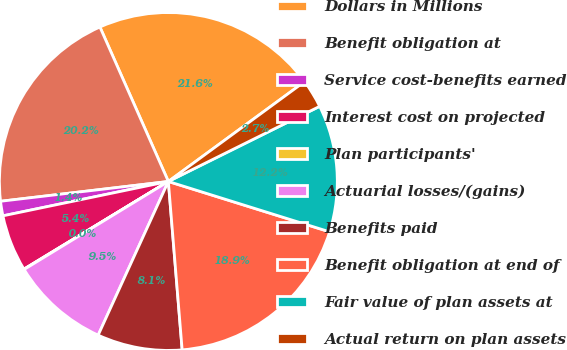Convert chart. <chart><loc_0><loc_0><loc_500><loc_500><pie_chart><fcel>Dollars in Millions<fcel>Benefit obligation at<fcel>Service cost-benefits earned<fcel>Interest cost on projected<fcel>Plan participants'<fcel>Actuarial losses/(gains)<fcel>Benefits paid<fcel>Benefit obligation at end of<fcel>Fair value of plan assets at<fcel>Actual return on plan assets<nl><fcel>21.57%<fcel>20.23%<fcel>1.39%<fcel>5.42%<fcel>0.04%<fcel>9.46%<fcel>8.12%<fcel>18.88%<fcel>12.15%<fcel>2.73%<nl></chart> 